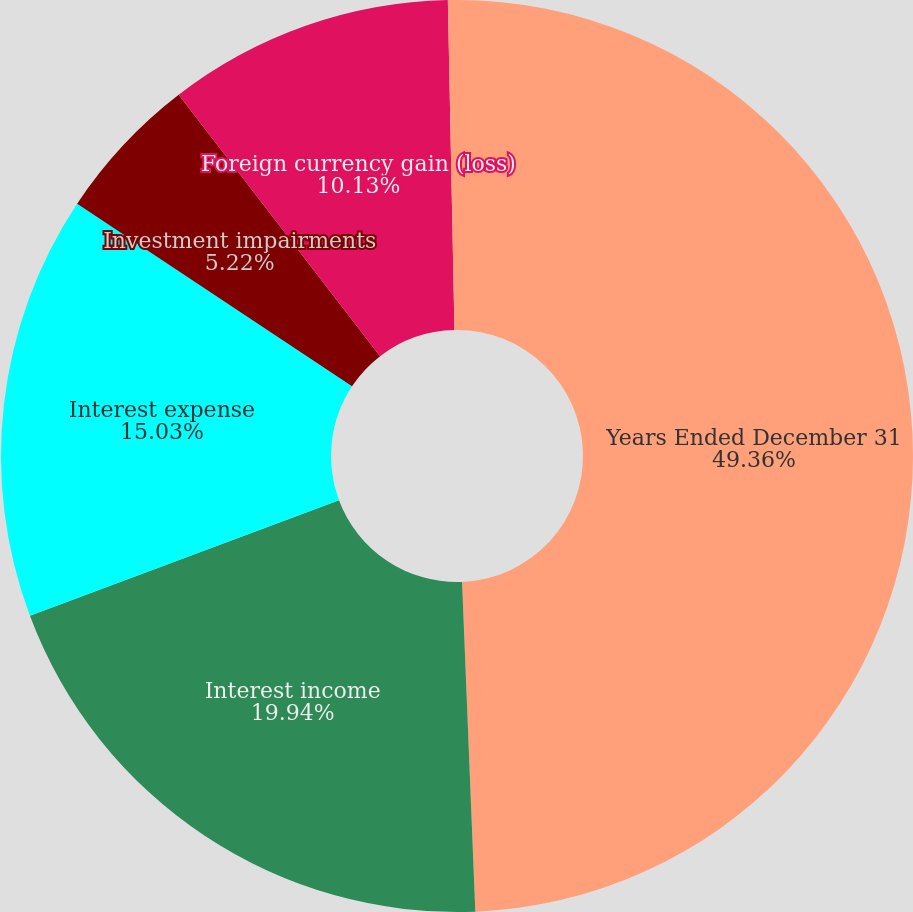Convert chart. <chart><loc_0><loc_0><loc_500><loc_500><pie_chart><fcel>Years Ended December 31<fcel>Interest income<fcel>Interest expense<fcel>Investment impairments<fcel>Foreign currency gain (loss)<fcel>Other<nl><fcel>49.36%<fcel>19.94%<fcel>15.03%<fcel>5.22%<fcel>10.13%<fcel>0.32%<nl></chart> 